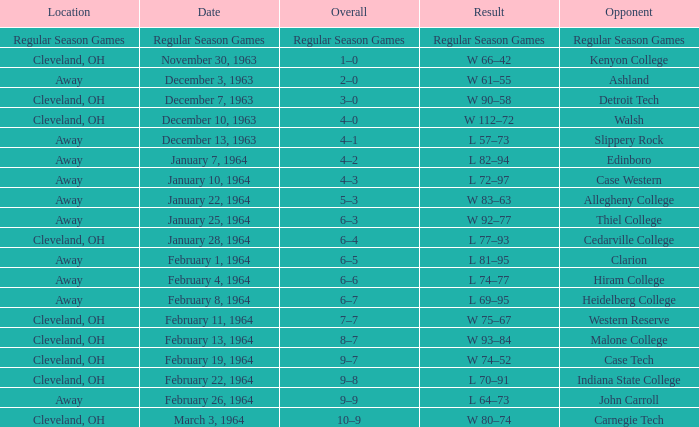What is the Location with a Date that is december 10, 1963? Cleveland, OH. Could you parse the entire table as a dict? {'header': ['Location', 'Date', 'Overall', 'Result', 'Opponent'], 'rows': [['Regular Season Games', 'Regular Season Games', 'Regular Season Games', 'Regular Season Games', 'Regular Season Games'], ['Cleveland, OH', 'November 30, 1963', '1–0', 'W 66–42', 'Kenyon College'], ['Away', 'December 3, 1963', '2–0', 'W 61–55', 'Ashland'], ['Cleveland, OH', 'December 7, 1963', '3–0', 'W 90–58', 'Detroit Tech'], ['Cleveland, OH', 'December 10, 1963', '4–0', 'W 112–72', 'Walsh'], ['Away', 'December 13, 1963', '4–1', 'L 57–73', 'Slippery Rock'], ['Away', 'January 7, 1964', '4–2', 'L 82–94', 'Edinboro'], ['Away', 'January 10, 1964', '4–3', 'L 72–97', 'Case Western'], ['Away', 'January 22, 1964', '5–3', 'W 83–63', 'Allegheny College'], ['Away', 'January 25, 1964', '6–3', 'W 92–77', 'Thiel College'], ['Cleveland, OH', 'January 28, 1964', '6–4', 'L 77–93', 'Cedarville College'], ['Away', 'February 1, 1964', '6–5', 'L 81–95', 'Clarion'], ['Away', 'February 4, 1964', '6–6', 'L 74–77', 'Hiram College'], ['Away', 'February 8, 1964', '6–7', 'L 69–95', 'Heidelberg College'], ['Cleveland, OH', 'February 11, 1964', '7–7', 'W 75–67', 'Western Reserve'], ['Cleveland, OH', 'February 13, 1964', '8–7', 'W 93–84', 'Malone College'], ['Cleveland, OH', 'February 19, 1964', '9–7', 'W 74–52', 'Case Tech'], ['Cleveland, OH', 'February 22, 1964', '9–8', 'L 70–91', 'Indiana State College'], ['Away', 'February 26, 1964', '9–9', 'L 64–73', 'John Carroll'], ['Cleveland, OH', 'March 3, 1964', '10–9', 'W 80–74', 'Carnegie Tech']]} 